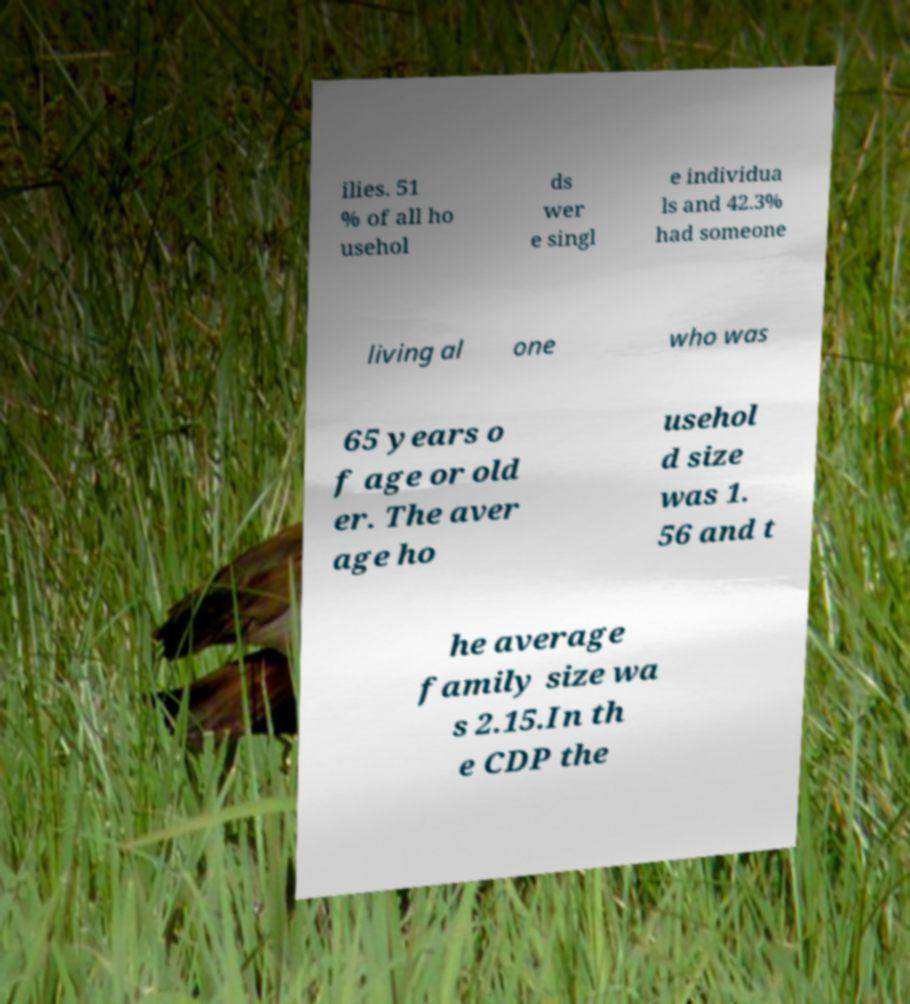Could you extract and type out the text from this image? ilies. 51 % of all ho usehol ds wer e singl e individua ls and 42.3% had someone living al one who was 65 years o f age or old er. The aver age ho usehol d size was 1. 56 and t he average family size wa s 2.15.In th e CDP the 